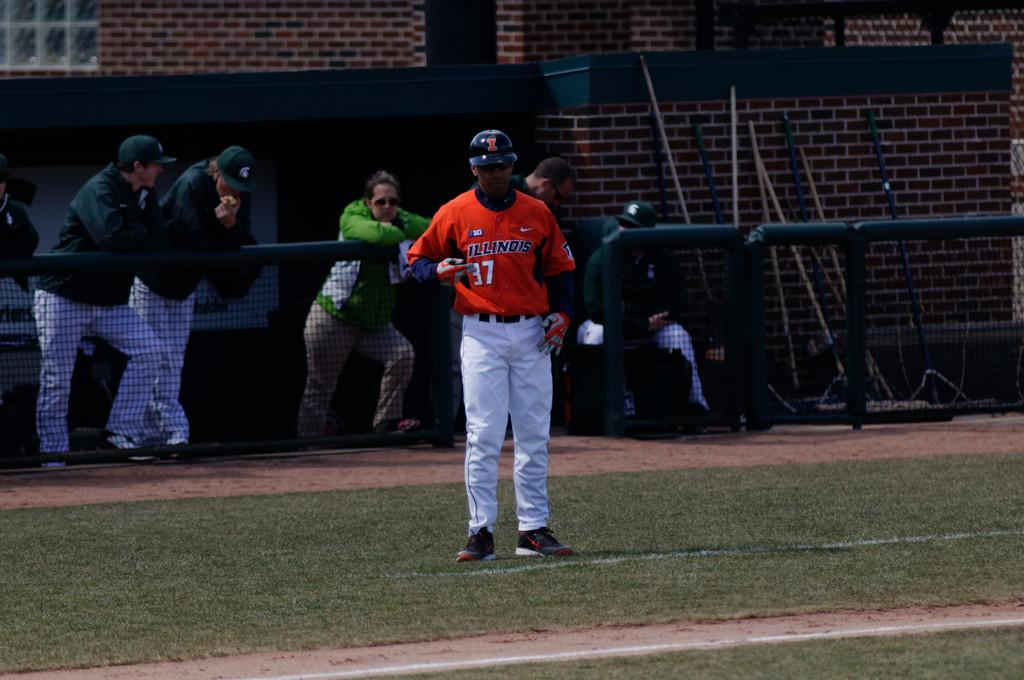Provide a one-sentence caption for the provided image. A baseball player in a red top bearing the number 37 stands on the field whilst behind him, several spectators look on. 